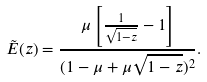<formula> <loc_0><loc_0><loc_500><loc_500>\tilde { E } ( z ) = \frac { \mu \left [ \frac { 1 } { \sqrt { 1 - z } } - 1 \right ] } { ( 1 - \mu + \mu \sqrt { 1 - z } ) ^ { 2 } } .</formula> 